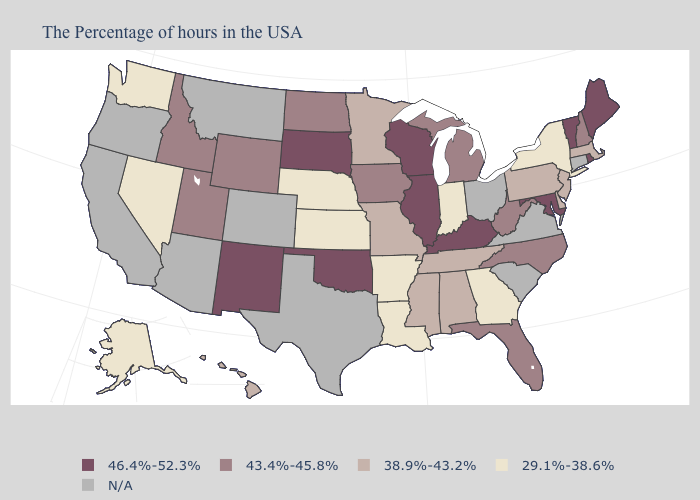Does the first symbol in the legend represent the smallest category?
Answer briefly. No. What is the value of Wisconsin?
Give a very brief answer. 46.4%-52.3%. Which states have the lowest value in the USA?
Quick response, please. New York, Georgia, Indiana, Louisiana, Arkansas, Kansas, Nebraska, Nevada, Washington, Alaska. Does Minnesota have the highest value in the MidWest?
Concise answer only. No. What is the value of Kansas?
Give a very brief answer. 29.1%-38.6%. Does North Carolina have the lowest value in the USA?
Quick response, please. No. Among the states that border Virginia , which have the lowest value?
Give a very brief answer. Tennessee. Does the map have missing data?
Short answer required. Yes. What is the lowest value in the MidWest?
Quick response, please. 29.1%-38.6%. Name the states that have a value in the range 46.4%-52.3%?
Answer briefly. Maine, Rhode Island, Vermont, Maryland, Kentucky, Wisconsin, Illinois, Oklahoma, South Dakota, New Mexico. What is the value of Nebraska?
Short answer required. 29.1%-38.6%. Among the states that border New Mexico , which have the lowest value?
Short answer required. Utah. Name the states that have a value in the range 43.4%-45.8%?
Quick response, please. New Hampshire, North Carolina, West Virginia, Florida, Michigan, Iowa, North Dakota, Wyoming, Utah, Idaho. What is the value of Arkansas?
Concise answer only. 29.1%-38.6%. Among the states that border North Dakota , which have the highest value?
Short answer required. South Dakota. 